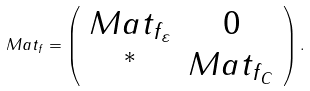<formula> <loc_0><loc_0><loc_500><loc_500>M a t _ { f } = \left ( \begin{array} { c c } M a t _ { f _ { \varepsilon } } & 0 \\ ^ { * } & M a t _ { f _ { C } } \end{array} \right ) .</formula> 